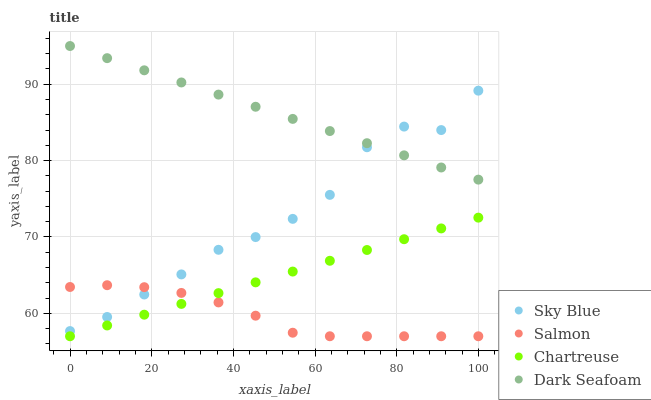Does Salmon have the minimum area under the curve?
Answer yes or no. Yes. Does Dark Seafoam have the maximum area under the curve?
Answer yes or no. Yes. Does Chartreuse have the minimum area under the curve?
Answer yes or no. No. Does Chartreuse have the maximum area under the curve?
Answer yes or no. No. Is Dark Seafoam the smoothest?
Answer yes or no. Yes. Is Sky Blue the roughest?
Answer yes or no. Yes. Is Chartreuse the smoothest?
Answer yes or no. No. Is Chartreuse the roughest?
Answer yes or no. No. Does Chartreuse have the lowest value?
Answer yes or no. Yes. Does Dark Seafoam have the lowest value?
Answer yes or no. No. Does Dark Seafoam have the highest value?
Answer yes or no. Yes. Does Chartreuse have the highest value?
Answer yes or no. No. Is Chartreuse less than Sky Blue?
Answer yes or no. Yes. Is Sky Blue greater than Chartreuse?
Answer yes or no. Yes. Does Sky Blue intersect Salmon?
Answer yes or no. Yes. Is Sky Blue less than Salmon?
Answer yes or no. No. Is Sky Blue greater than Salmon?
Answer yes or no. No. Does Chartreuse intersect Sky Blue?
Answer yes or no. No. 